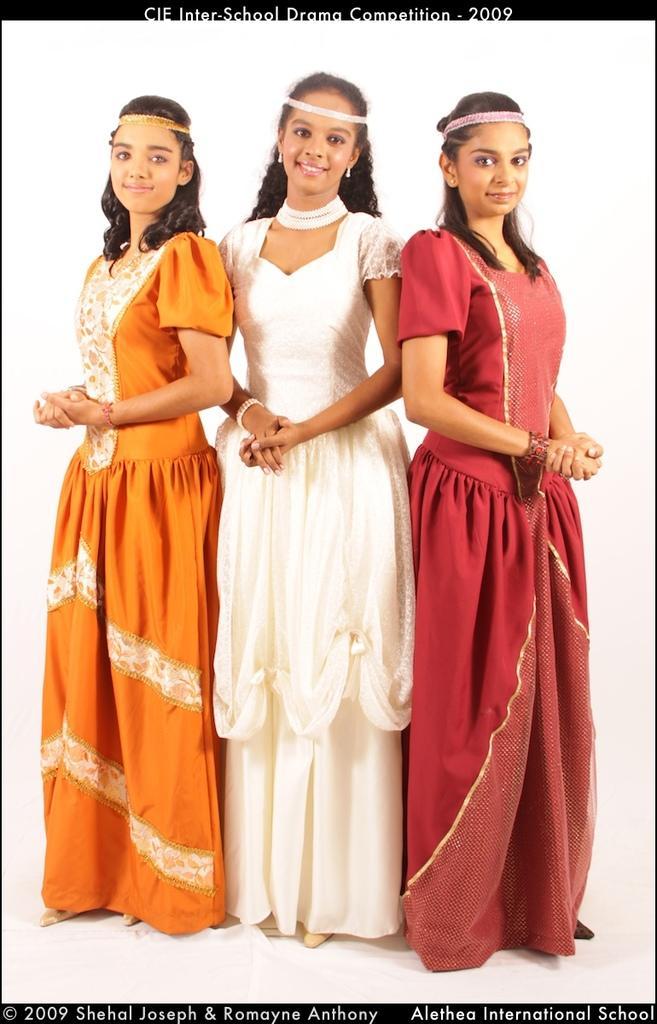Could you give a brief overview of what you see in this image? In this image we can see this woman wearing orange color dress, this woman wearing white color dress and this woman wearing maroon color dress are standing here and smiling. Here we can see the watermark on the top and bottom of the image. 